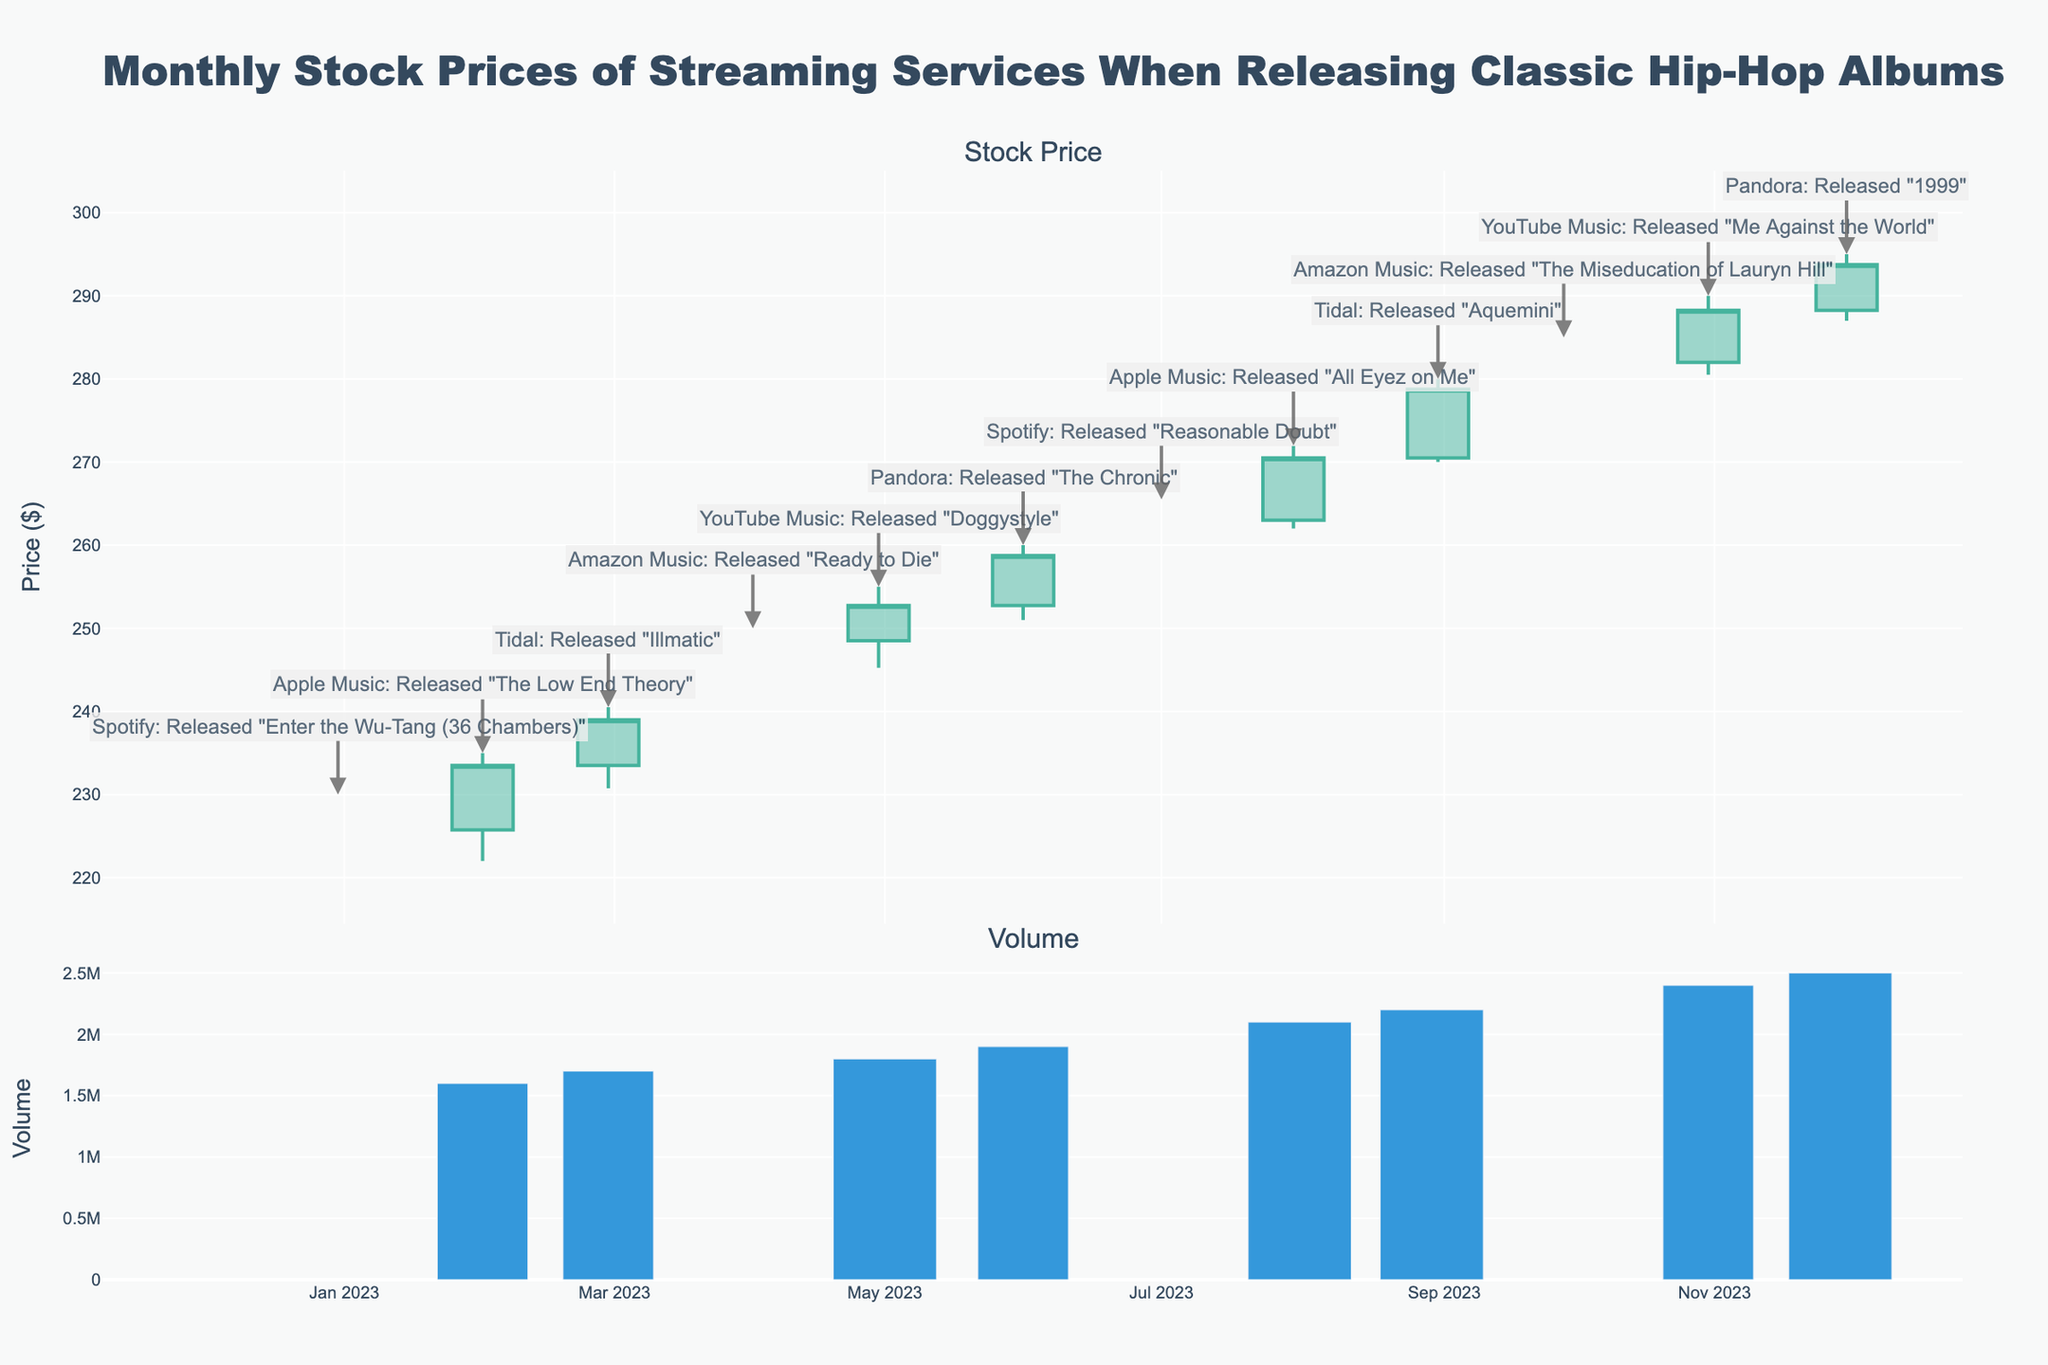What is the highest stock price observed in the given data? The highest stock price can be identified by looking for the maximum value in the 'High' section of the candlestick plot. For October 2023, the price reached as high as $285.00 when Amazon Music released "The Miseducation of Lauryn Hill".
Answer: $285.00 Which month had the highest trading volume? To determine the month with the highest trading volume, check the bar chart in the second subplot to find the month with the longest bar. December 2023 has the highest volume when Pandora released "1999".
Answer: December 2023 How did the stock price change from January to December 2023? To find the change in stock price, subtract the closing price in January ($225.75) from the closing price in December ($293.75). The stock price increased by $67.00.
Answer: Increased by $67.00 Which company's release saw the greatest increase in stock price? Identify the months where different companies released albums and compare the increase in stock price from the opening to the closing value. For April 2023, Amazon Music's release of "Ready to Die" saw the stock price increase from $239.00 to $248.50, an increase of $9.50.
Answer: Amazon Music What is the total trading volume over the year 2023? Sum the trading volumes for each month: 1500000 + 1600000 + 1700000 + 1750000 + 1800000 + 1900000 + 2000000 + 2100000 + 2200000 + 2300000 + 2400000 + 2500000 = 24750000.
Answer: 24,750,000 Which month had the smallest difference between the high and low stock prices? Evaluate the difference between the 'High' and 'Low' prices for each month and find the one with the smallest value. In January 2023, the difference is 230.00 - 219.00 = 11.00. This is the smallest compared to other months.
Answer: January 2023 How does the average closing price from the first half of the year compare to the second half? Find the average of the closing prices from January to June and from July to December, then compare. 
1st half: (225.75 + 233.50 + 239.00 + 248.50 + 252.75 + 258.75) / 6 = 243.06; 
2nd half: (263.00 + 270.50 + 278.75 + 282.00 + 288.25 + 293.75) / 6 = 279.71.
The average closing price is higher in the second half.
Answer: Higher in the second half On which month did YouTube Music release an album, and what was the closing price that month? Look for the month when YouTube Music released an album and check the closing price. In May 2023, YouTube Music released "Doggystyle" with the closing price at $252.75.
Answer: May 2023, $252.75 What was the closing price trend for Spotify based on the two albums they released? Identify the months Spotify released albums and compare the closing prices. In January, the closing price was $225.75, and in July, it was $263.00, showing an upward trend.
Answer: Upward trend 